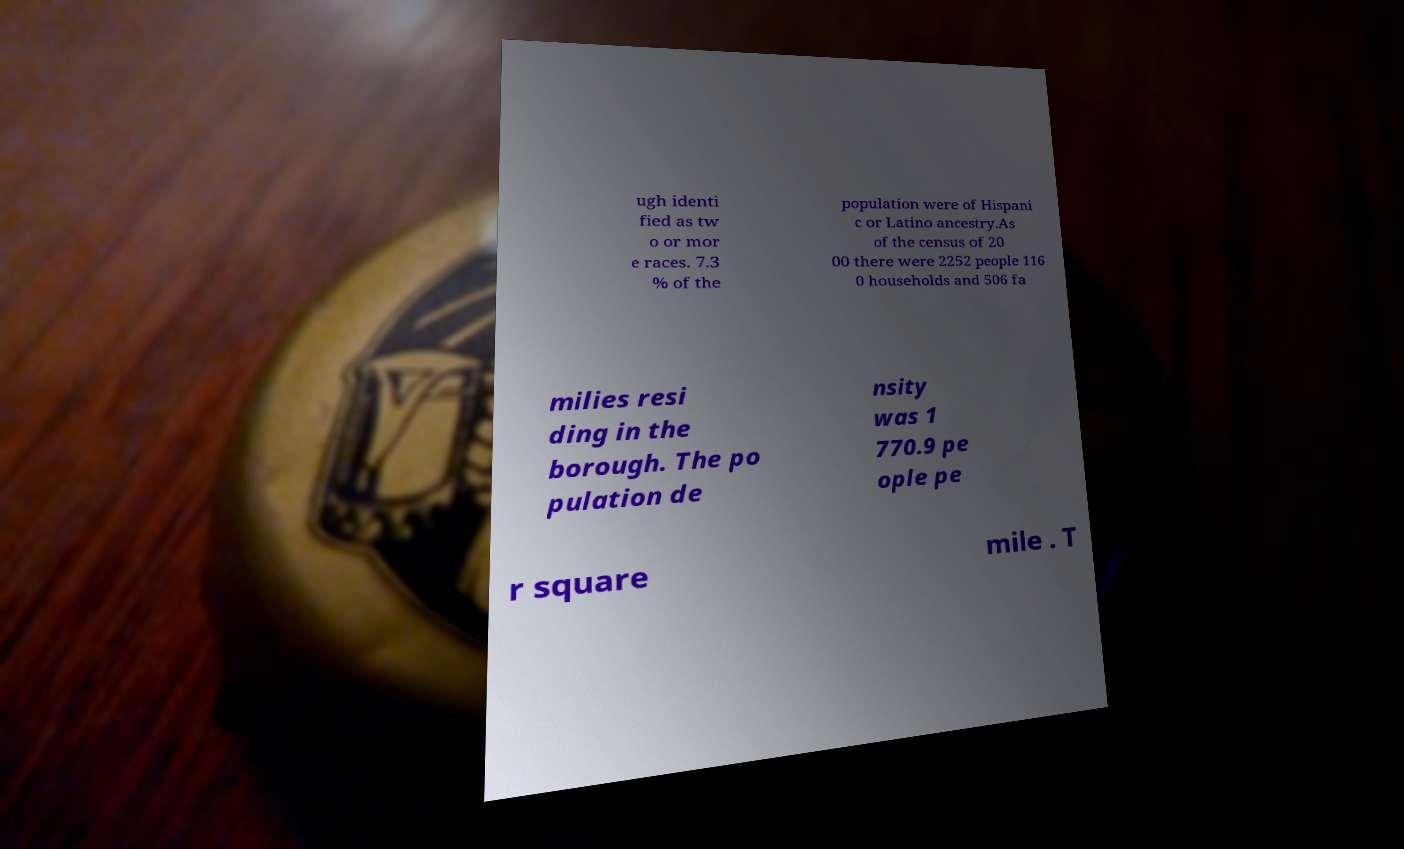Could you extract and type out the text from this image? ugh identi fied as tw o or mor e races. 7.3 % of the population were of Hispani c or Latino ancestry.As of the census of 20 00 there were 2252 people 116 0 households and 506 fa milies resi ding in the borough. The po pulation de nsity was 1 770.9 pe ople pe r square mile . T 